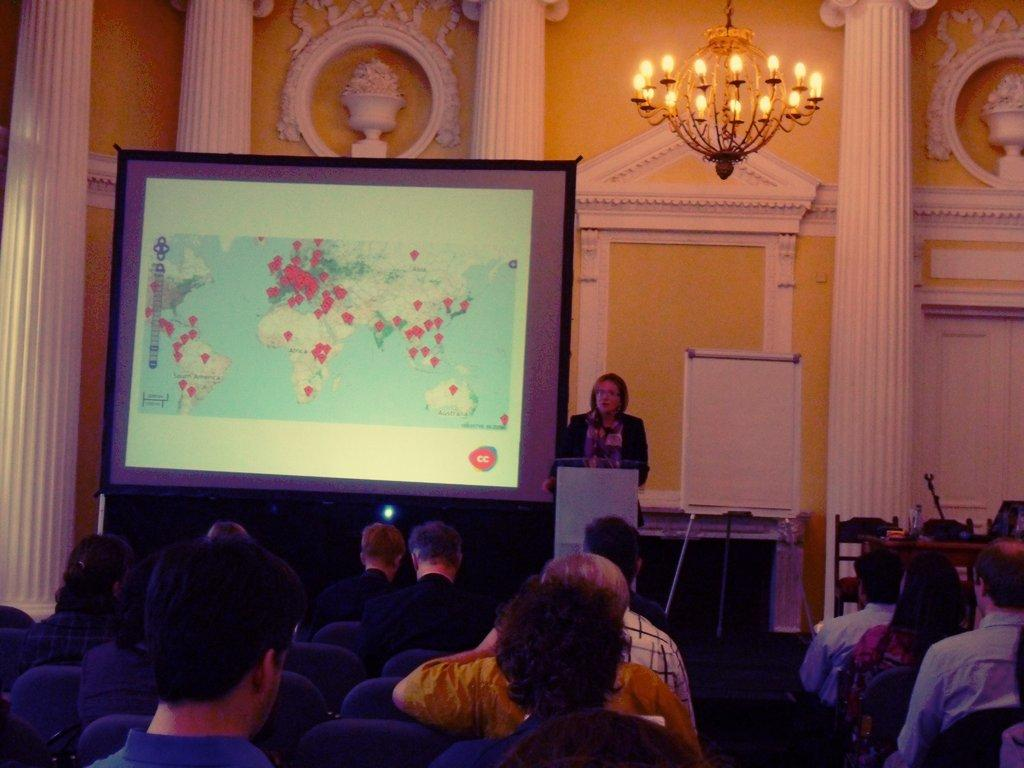What are the people in the image doing? There is a group of people sitting in the image. What can be seen in the background of the image? There is a projector screen in the background of the image. Is there anyone standing in the image? Yes, there is a person standing in the image. What color is the wall in the background? The wall in the background has a cream color. What type of plane is flying over the group of people in the image? There is no plane visible in the image. The focus is on the group of people sitting and the person standing, along with the projector screen and the cream-colored wall in the background. 